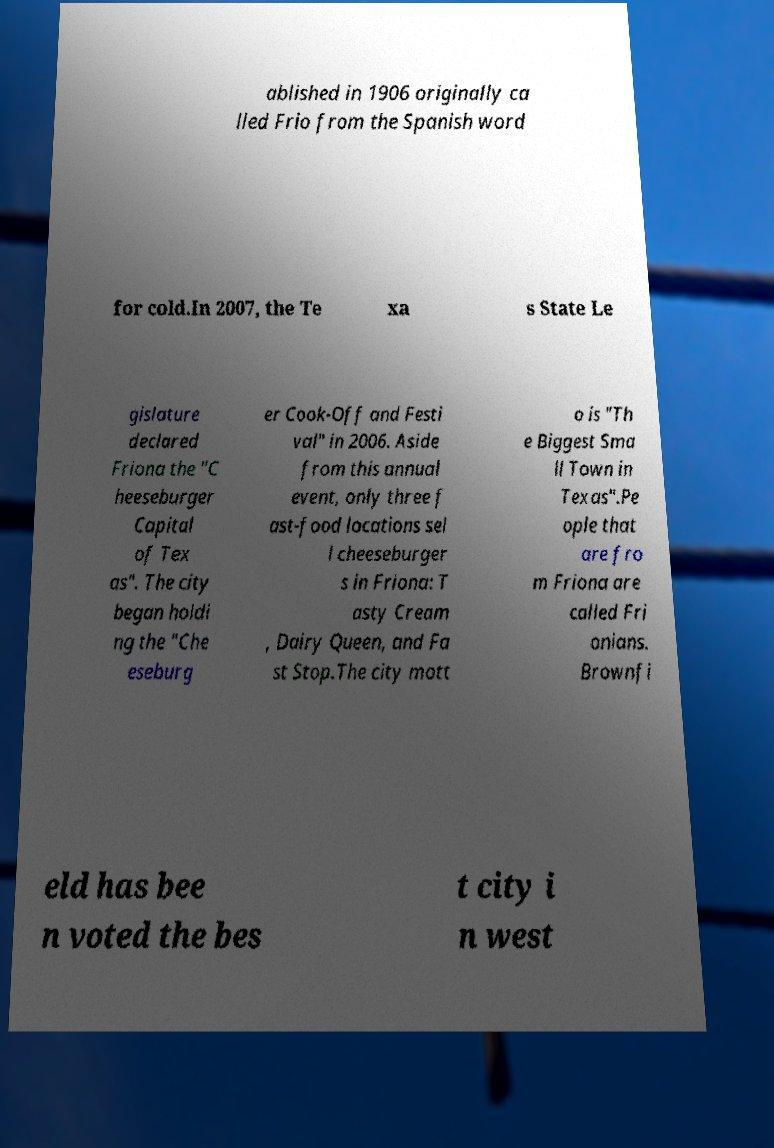Please read and relay the text visible in this image. What does it say? ablished in 1906 originally ca lled Frio from the Spanish word for cold.In 2007, the Te xa s State Le gislature declared Friona the "C heeseburger Capital of Tex as". The city began holdi ng the "Che eseburg er Cook-Off and Festi val" in 2006. Aside from this annual event, only three f ast-food locations sel l cheeseburger s in Friona: T asty Cream , Dairy Queen, and Fa st Stop.The city mott o is "Th e Biggest Sma ll Town in Texas".Pe ople that are fro m Friona are called Fri onians. Brownfi eld has bee n voted the bes t city i n west 